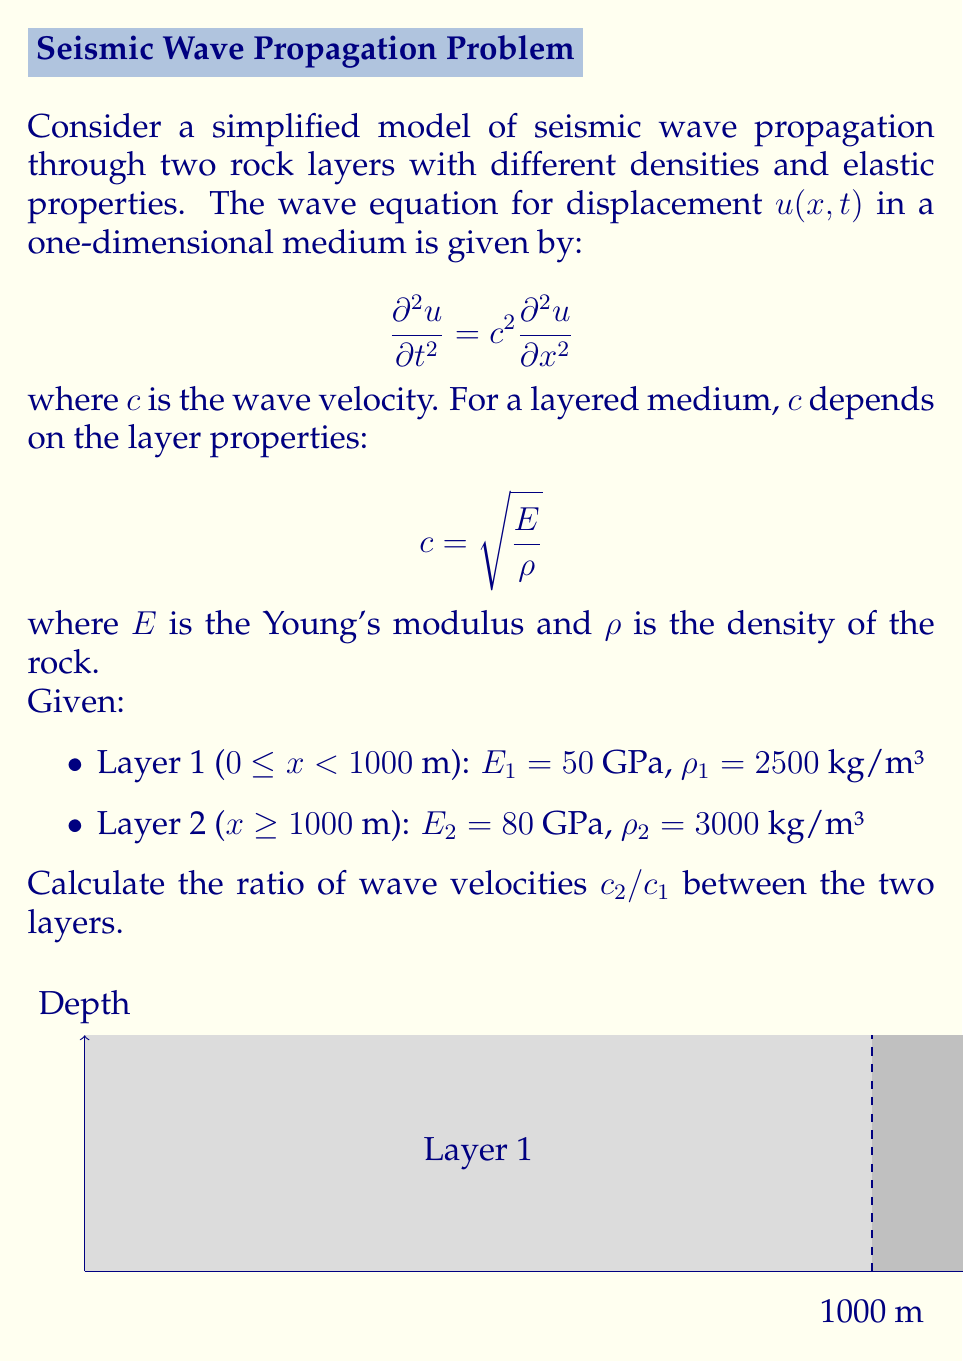Show me your answer to this math problem. To solve this problem, we'll follow these steps:

1) First, recall the equation for wave velocity in each layer:
   $$c = \sqrt{\frac{E}{\rho}}$$

2) Calculate the wave velocity in Layer 1:
   $$c_1 = \sqrt{\frac{E_1}{\rho_1}} = \sqrt{\frac{50 \times 10^9}{2500}} = \sqrt{20 \times 10^6} = 4472.14 \text{ m/s}$$

3) Calculate the wave velocity in Layer 2:
   $$c_2 = \sqrt{\frac{E_2}{\rho_2}} = \sqrt{\frac{80 \times 10^9}{3000}} = \sqrt{26.67 \times 10^6} = 5163.98 \text{ m/s}$$

4) Calculate the ratio of wave velocities:
   $$\frac{c_2}{c_1} = \frac{5163.98}{4472.14} = 1.1547$$

This ratio indicates that the seismic waves travel approximately 15.47% faster in the second layer compared to the first layer.
Answer: $\frac{c_2}{c_1} = 1.1547$ 